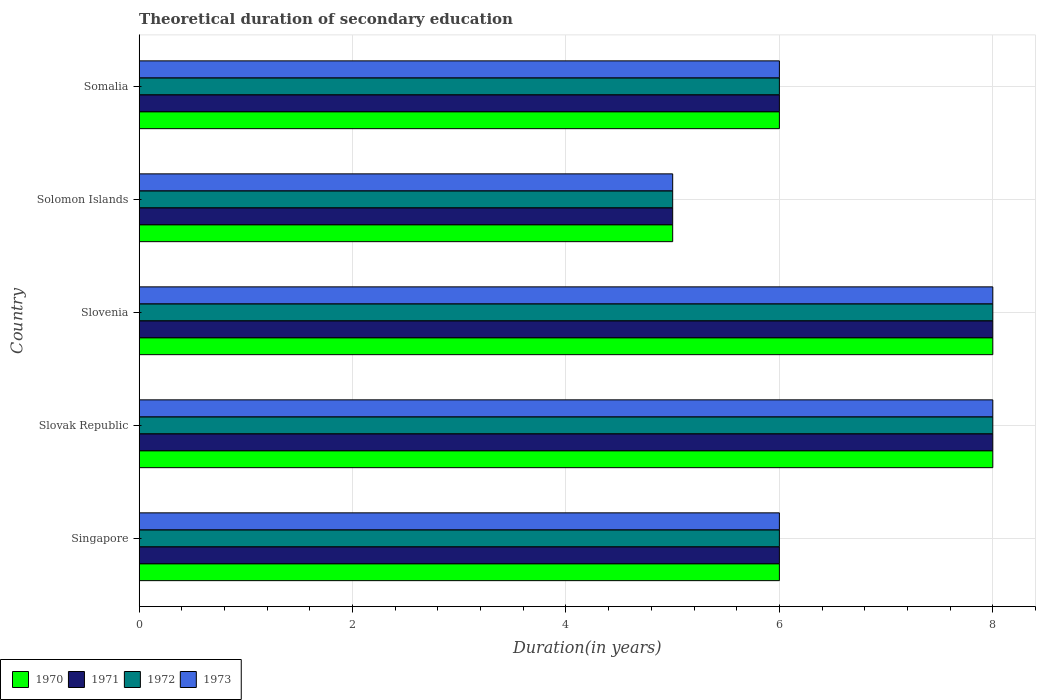How many groups of bars are there?
Offer a very short reply. 5. Are the number of bars on each tick of the Y-axis equal?
Provide a short and direct response. Yes. How many bars are there on the 4th tick from the top?
Provide a short and direct response. 4. How many bars are there on the 1st tick from the bottom?
Your answer should be compact. 4. What is the label of the 3rd group of bars from the top?
Make the answer very short. Slovenia. Across all countries, what is the minimum total theoretical duration of secondary education in 1970?
Offer a terse response. 5. In which country was the total theoretical duration of secondary education in 1971 maximum?
Give a very brief answer. Slovak Republic. In which country was the total theoretical duration of secondary education in 1973 minimum?
Offer a terse response. Solomon Islands. What is the total total theoretical duration of secondary education in 1972 in the graph?
Your response must be concise. 33. What is the difference between the total theoretical duration of secondary education in 1972 in Singapore and that in Somalia?
Your answer should be compact. 0. What is the difference between the total theoretical duration of secondary education in 1971 in Slovenia and the total theoretical duration of secondary education in 1970 in Slovak Republic?
Your answer should be compact. 0. What is the difference between the total theoretical duration of secondary education in 1973 and total theoretical duration of secondary education in 1970 in Singapore?
Provide a short and direct response. 0. Is the total theoretical duration of secondary education in 1973 in Slovak Republic less than that in Solomon Islands?
Offer a very short reply. No. Is the difference between the total theoretical duration of secondary education in 1973 in Slovenia and Somalia greater than the difference between the total theoretical duration of secondary education in 1970 in Slovenia and Somalia?
Give a very brief answer. No. What is the difference between the highest and the lowest total theoretical duration of secondary education in 1971?
Keep it short and to the point. 3. Is it the case that in every country, the sum of the total theoretical duration of secondary education in 1972 and total theoretical duration of secondary education in 1970 is greater than the total theoretical duration of secondary education in 1973?
Your answer should be very brief. Yes. How many countries are there in the graph?
Provide a succinct answer. 5. Are the values on the major ticks of X-axis written in scientific E-notation?
Your response must be concise. No. Where does the legend appear in the graph?
Make the answer very short. Bottom left. What is the title of the graph?
Provide a short and direct response. Theoretical duration of secondary education. Does "1990" appear as one of the legend labels in the graph?
Offer a terse response. No. What is the label or title of the X-axis?
Ensure brevity in your answer.  Duration(in years). What is the label or title of the Y-axis?
Provide a short and direct response. Country. What is the Duration(in years) of 1970 in Singapore?
Keep it short and to the point. 6. What is the Duration(in years) in 1973 in Singapore?
Your answer should be very brief. 6. What is the Duration(in years) of 1970 in Slovak Republic?
Keep it short and to the point. 8. What is the Duration(in years) of 1971 in Slovak Republic?
Provide a succinct answer. 8. What is the Duration(in years) in 1972 in Slovak Republic?
Provide a succinct answer. 8. What is the Duration(in years) of 1971 in Slovenia?
Your answer should be very brief. 8. What is the Duration(in years) of 1971 in Solomon Islands?
Your response must be concise. 5. What is the Duration(in years) of 1973 in Solomon Islands?
Your answer should be compact. 5. What is the Duration(in years) in 1973 in Somalia?
Give a very brief answer. 6. Across all countries, what is the maximum Duration(in years) in 1970?
Offer a terse response. 8. Across all countries, what is the maximum Duration(in years) of 1971?
Your response must be concise. 8. Across all countries, what is the maximum Duration(in years) in 1972?
Your answer should be compact. 8. Across all countries, what is the maximum Duration(in years) in 1973?
Your response must be concise. 8. Across all countries, what is the minimum Duration(in years) of 1970?
Keep it short and to the point. 5. Across all countries, what is the minimum Duration(in years) in 1972?
Offer a terse response. 5. Across all countries, what is the minimum Duration(in years) in 1973?
Provide a short and direct response. 5. What is the total Duration(in years) in 1971 in the graph?
Your response must be concise. 33. What is the difference between the Duration(in years) in 1970 in Singapore and that in Slovak Republic?
Offer a terse response. -2. What is the difference between the Duration(in years) in 1972 in Singapore and that in Slovak Republic?
Provide a succinct answer. -2. What is the difference between the Duration(in years) in 1973 in Singapore and that in Slovak Republic?
Provide a succinct answer. -2. What is the difference between the Duration(in years) in 1971 in Singapore and that in Slovenia?
Your answer should be compact. -2. What is the difference between the Duration(in years) in 1972 in Singapore and that in Slovenia?
Your response must be concise. -2. What is the difference between the Duration(in years) of 1973 in Singapore and that in Slovenia?
Ensure brevity in your answer.  -2. What is the difference between the Duration(in years) in 1970 in Singapore and that in Solomon Islands?
Your answer should be compact. 1. What is the difference between the Duration(in years) in 1972 in Singapore and that in Solomon Islands?
Your response must be concise. 1. What is the difference between the Duration(in years) of 1973 in Singapore and that in Solomon Islands?
Your response must be concise. 1. What is the difference between the Duration(in years) in 1970 in Singapore and that in Somalia?
Your answer should be very brief. 0. What is the difference between the Duration(in years) of 1972 in Singapore and that in Somalia?
Give a very brief answer. 0. What is the difference between the Duration(in years) of 1971 in Slovak Republic and that in Slovenia?
Your answer should be very brief. 0. What is the difference between the Duration(in years) of 1972 in Slovak Republic and that in Slovenia?
Ensure brevity in your answer.  0. What is the difference between the Duration(in years) in 1970 in Slovak Republic and that in Solomon Islands?
Provide a short and direct response. 3. What is the difference between the Duration(in years) of 1972 in Slovak Republic and that in Solomon Islands?
Offer a very short reply. 3. What is the difference between the Duration(in years) of 1973 in Slovak Republic and that in Solomon Islands?
Provide a succinct answer. 3. What is the difference between the Duration(in years) of 1970 in Slovak Republic and that in Somalia?
Your answer should be compact. 2. What is the difference between the Duration(in years) in 1973 in Slovak Republic and that in Somalia?
Ensure brevity in your answer.  2. What is the difference between the Duration(in years) in 1972 in Slovenia and that in Solomon Islands?
Make the answer very short. 3. What is the difference between the Duration(in years) in 1970 in Slovenia and that in Somalia?
Provide a succinct answer. 2. What is the difference between the Duration(in years) in 1972 in Slovenia and that in Somalia?
Your response must be concise. 2. What is the difference between the Duration(in years) in 1973 in Slovenia and that in Somalia?
Give a very brief answer. 2. What is the difference between the Duration(in years) of 1970 in Solomon Islands and that in Somalia?
Make the answer very short. -1. What is the difference between the Duration(in years) of 1972 in Solomon Islands and that in Somalia?
Your answer should be compact. -1. What is the difference between the Duration(in years) in 1973 in Solomon Islands and that in Somalia?
Your answer should be very brief. -1. What is the difference between the Duration(in years) in 1970 in Singapore and the Duration(in years) in 1971 in Slovak Republic?
Ensure brevity in your answer.  -2. What is the difference between the Duration(in years) in 1970 in Singapore and the Duration(in years) in 1973 in Slovak Republic?
Provide a short and direct response. -2. What is the difference between the Duration(in years) in 1971 in Singapore and the Duration(in years) in 1973 in Slovak Republic?
Offer a very short reply. -2. What is the difference between the Duration(in years) of 1970 in Singapore and the Duration(in years) of 1971 in Slovenia?
Give a very brief answer. -2. What is the difference between the Duration(in years) of 1970 in Singapore and the Duration(in years) of 1972 in Slovenia?
Give a very brief answer. -2. What is the difference between the Duration(in years) in 1971 in Singapore and the Duration(in years) in 1972 in Slovenia?
Your answer should be very brief. -2. What is the difference between the Duration(in years) in 1970 in Singapore and the Duration(in years) in 1971 in Solomon Islands?
Ensure brevity in your answer.  1. What is the difference between the Duration(in years) in 1970 in Singapore and the Duration(in years) in 1972 in Solomon Islands?
Provide a short and direct response. 1. What is the difference between the Duration(in years) in 1972 in Singapore and the Duration(in years) in 1973 in Solomon Islands?
Provide a short and direct response. 1. What is the difference between the Duration(in years) in 1970 in Singapore and the Duration(in years) in 1971 in Somalia?
Give a very brief answer. 0. What is the difference between the Duration(in years) of 1970 in Singapore and the Duration(in years) of 1973 in Somalia?
Give a very brief answer. 0. What is the difference between the Duration(in years) of 1971 in Singapore and the Duration(in years) of 1972 in Somalia?
Offer a terse response. 0. What is the difference between the Duration(in years) in 1970 in Slovak Republic and the Duration(in years) in 1971 in Slovenia?
Offer a terse response. 0. What is the difference between the Duration(in years) in 1970 in Slovak Republic and the Duration(in years) in 1973 in Slovenia?
Your response must be concise. 0. What is the difference between the Duration(in years) in 1971 in Slovak Republic and the Duration(in years) in 1972 in Slovenia?
Provide a succinct answer. 0. What is the difference between the Duration(in years) in 1971 in Slovak Republic and the Duration(in years) in 1973 in Slovenia?
Provide a short and direct response. 0. What is the difference between the Duration(in years) of 1972 in Slovak Republic and the Duration(in years) of 1973 in Slovenia?
Your response must be concise. 0. What is the difference between the Duration(in years) in 1970 in Slovak Republic and the Duration(in years) in 1971 in Solomon Islands?
Provide a short and direct response. 3. What is the difference between the Duration(in years) in 1970 in Slovak Republic and the Duration(in years) in 1972 in Solomon Islands?
Provide a succinct answer. 3. What is the difference between the Duration(in years) of 1971 in Slovak Republic and the Duration(in years) of 1973 in Solomon Islands?
Provide a short and direct response. 3. What is the difference between the Duration(in years) of 1972 in Slovak Republic and the Duration(in years) of 1973 in Solomon Islands?
Offer a terse response. 3. What is the difference between the Duration(in years) in 1970 in Slovak Republic and the Duration(in years) in 1971 in Somalia?
Keep it short and to the point. 2. What is the difference between the Duration(in years) in 1971 in Slovak Republic and the Duration(in years) in 1972 in Somalia?
Offer a terse response. 2. What is the difference between the Duration(in years) in 1970 in Slovenia and the Duration(in years) in 1971 in Solomon Islands?
Ensure brevity in your answer.  3. What is the difference between the Duration(in years) in 1970 in Slovenia and the Duration(in years) in 1972 in Solomon Islands?
Provide a short and direct response. 3. What is the difference between the Duration(in years) in 1970 in Slovenia and the Duration(in years) in 1973 in Solomon Islands?
Offer a terse response. 3. What is the difference between the Duration(in years) in 1971 in Slovenia and the Duration(in years) in 1972 in Solomon Islands?
Your response must be concise. 3. What is the difference between the Duration(in years) in 1970 in Slovenia and the Duration(in years) in 1973 in Somalia?
Your response must be concise. 2. What is the difference between the Duration(in years) of 1971 in Slovenia and the Duration(in years) of 1972 in Somalia?
Your answer should be compact. 2. What is the difference between the Duration(in years) in 1971 in Slovenia and the Duration(in years) in 1973 in Somalia?
Your answer should be compact. 2. What is the difference between the Duration(in years) of 1970 in Solomon Islands and the Duration(in years) of 1971 in Somalia?
Make the answer very short. -1. What is the difference between the Duration(in years) of 1970 in Solomon Islands and the Duration(in years) of 1973 in Somalia?
Your response must be concise. -1. What is the average Duration(in years) of 1970 per country?
Your answer should be very brief. 6.6. What is the average Duration(in years) in 1972 per country?
Your answer should be very brief. 6.6. What is the difference between the Duration(in years) of 1970 and Duration(in years) of 1972 in Singapore?
Ensure brevity in your answer.  0. What is the difference between the Duration(in years) in 1970 and Duration(in years) in 1973 in Singapore?
Give a very brief answer. 0. What is the difference between the Duration(in years) of 1971 and Duration(in years) of 1973 in Singapore?
Keep it short and to the point. 0. What is the difference between the Duration(in years) in 1972 and Duration(in years) in 1973 in Singapore?
Give a very brief answer. 0. What is the difference between the Duration(in years) of 1970 and Duration(in years) of 1971 in Slovak Republic?
Make the answer very short. 0. What is the difference between the Duration(in years) in 1970 and Duration(in years) in 1973 in Slovak Republic?
Provide a succinct answer. 0. What is the difference between the Duration(in years) in 1971 and Duration(in years) in 1972 in Slovak Republic?
Keep it short and to the point. 0. What is the difference between the Duration(in years) of 1970 and Duration(in years) of 1971 in Slovenia?
Your answer should be very brief. 0. What is the difference between the Duration(in years) in 1971 and Duration(in years) in 1972 in Slovenia?
Your answer should be compact. 0. What is the difference between the Duration(in years) in 1972 and Duration(in years) in 1973 in Slovenia?
Your answer should be very brief. 0. What is the difference between the Duration(in years) in 1970 and Duration(in years) in 1972 in Solomon Islands?
Your answer should be very brief. 0. What is the difference between the Duration(in years) of 1971 and Duration(in years) of 1972 in Solomon Islands?
Offer a terse response. 0. What is the difference between the Duration(in years) of 1971 and Duration(in years) of 1973 in Solomon Islands?
Your answer should be compact. 0. What is the difference between the Duration(in years) of 1970 and Duration(in years) of 1971 in Somalia?
Your response must be concise. 0. What is the difference between the Duration(in years) in 1971 and Duration(in years) in 1972 in Somalia?
Your answer should be very brief. 0. What is the difference between the Duration(in years) of 1972 and Duration(in years) of 1973 in Somalia?
Offer a terse response. 0. What is the ratio of the Duration(in years) of 1971 in Singapore to that in Slovak Republic?
Make the answer very short. 0.75. What is the ratio of the Duration(in years) of 1971 in Singapore to that in Slovenia?
Keep it short and to the point. 0.75. What is the ratio of the Duration(in years) in 1970 in Singapore to that in Solomon Islands?
Make the answer very short. 1.2. What is the ratio of the Duration(in years) of 1972 in Singapore to that in Solomon Islands?
Make the answer very short. 1.2. What is the ratio of the Duration(in years) of 1973 in Singapore to that in Solomon Islands?
Your response must be concise. 1.2. What is the ratio of the Duration(in years) in 1971 in Singapore to that in Somalia?
Provide a succinct answer. 1. What is the ratio of the Duration(in years) in 1973 in Singapore to that in Somalia?
Keep it short and to the point. 1. What is the ratio of the Duration(in years) of 1971 in Slovak Republic to that in Slovenia?
Make the answer very short. 1. What is the ratio of the Duration(in years) of 1972 in Slovak Republic to that in Slovenia?
Offer a terse response. 1. What is the ratio of the Duration(in years) of 1973 in Slovak Republic to that in Slovenia?
Your response must be concise. 1. What is the ratio of the Duration(in years) of 1970 in Slovak Republic to that in Solomon Islands?
Offer a very short reply. 1.6. What is the ratio of the Duration(in years) of 1971 in Slovak Republic to that in Solomon Islands?
Keep it short and to the point. 1.6. What is the ratio of the Duration(in years) in 1972 in Slovak Republic to that in Solomon Islands?
Your answer should be compact. 1.6. What is the ratio of the Duration(in years) in 1973 in Slovak Republic to that in Solomon Islands?
Make the answer very short. 1.6. What is the ratio of the Duration(in years) in 1970 in Slovak Republic to that in Somalia?
Offer a very short reply. 1.33. What is the ratio of the Duration(in years) in 1971 in Slovak Republic to that in Somalia?
Your response must be concise. 1.33. What is the ratio of the Duration(in years) of 1972 in Slovak Republic to that in Somalia?
Your response must be concise. 1.33. What is the ratio of the Duration(in years) in 1973 in Slovak Republic to that in Somalia?
Make the answer very short. 1.33. What is the ratio of the Duration(in years) in 1970 in Slovenia to that in Solomon Islands?
Ensure brevity in your answer.  1.6. What is the ratio of the Duration(in years) of 1972 in Slovenia to that in Solomon Islands?
Make the answer very short. 1.6. What is the ratio of the Duration(in years) in 1973 in Slovenia to that in Solomon Islands?
Offer a very short reply. 1.6. What is the ratio of the Duration(in years) of 1970 in Slovenia to that in Somalia?
Offer a terse response. 1.33. What is the ratio of the Duration(in years) in 1971 in Slovenia to that in Somalia?
Offer a terse response. 1.33. What is the ratio of the Duration(in years) of 1972 in Slovenia to that in Somalia?
Provide a succinct answer. 1.33. What is the ratio of the Duration(in years) of 1973 in Slovenia to that in Somalia?
Provide a succinct answer. 1.33. What is the ratio of the Duration(in years) in 1970 in Solomon Islands to that in Somalia?
Your answer should be compact. 0.83. What is the ratio of the Duration(in years) of 1972 in Solomon Islands to that in Somalia?
Make the answer very short. 0.83. What is the ratio of the Duration(in years) of 1973 in Solomon Islands to that in Somalia?
Make the answer very short. 0.83. What is the difference between the highest and the lowest Duration(in years) in 1970?
Give a very brief answer. 3. What is the difference between the highest and the lowest Duration(in years) of 1972?
Your answer should be compact. 3. 